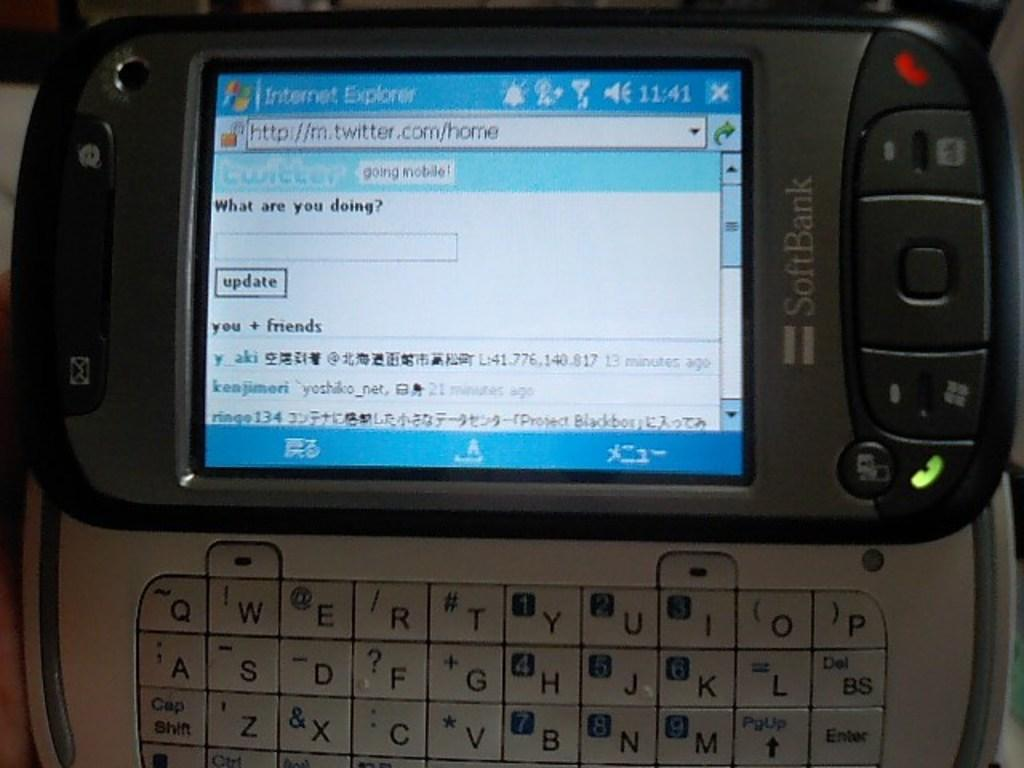Provide a one-sentence caption for the provided image. A phone screen is open to Internet Explorer. 